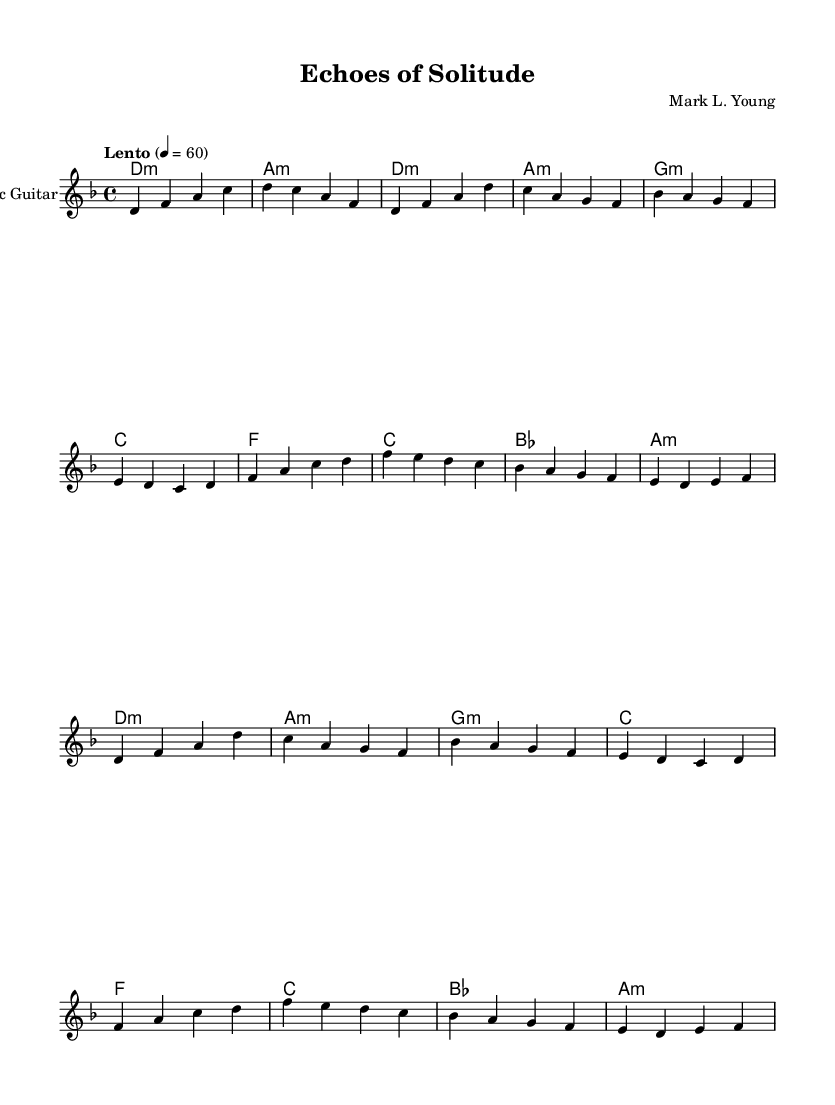What is the key signature of this music? The key signature is D minor, as indicated by the number of flats (one flat) and the overall tonality presented in the music.
Answer: D minor What is the time signature of this piece? The time signature is 4/4, which is common in popular music and allows for four beats per measure. This is clearly indicated at the beginning of the score.
Answer: 4/4 What is the tempo marking for this music? The tempo marking is "Lento," which indicates a slow pace, and is set at a metronome mark of 60 beats per minute. This is found at the start of the piece.
Answer: Lento How many measures are repeated in the piece? The piece includes a repetition of both the verse and the chorus, resulting in four measures from the verse and four from the chorus for a total of eight measures repeated.
Answer: Eight What instrument is specified in the score? The score specifically indicates "Acoustic Guitar" for the solo part, which is clearly labeled at the start of the guitar staff.
Answer: Acoustic Guitar What type of harmony is predominantly used in this music? The harmony utilizes a minor chord structure, as indicated by the chord names provided below the staff. Most chords are labeled with "m" representing minor chords.
Answer: Minor 